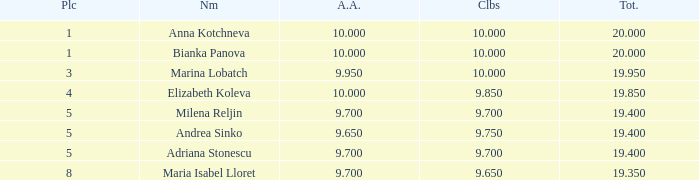What are the lowest clubs that have a place greater than 5, with an all around greater than 9.7? None. 